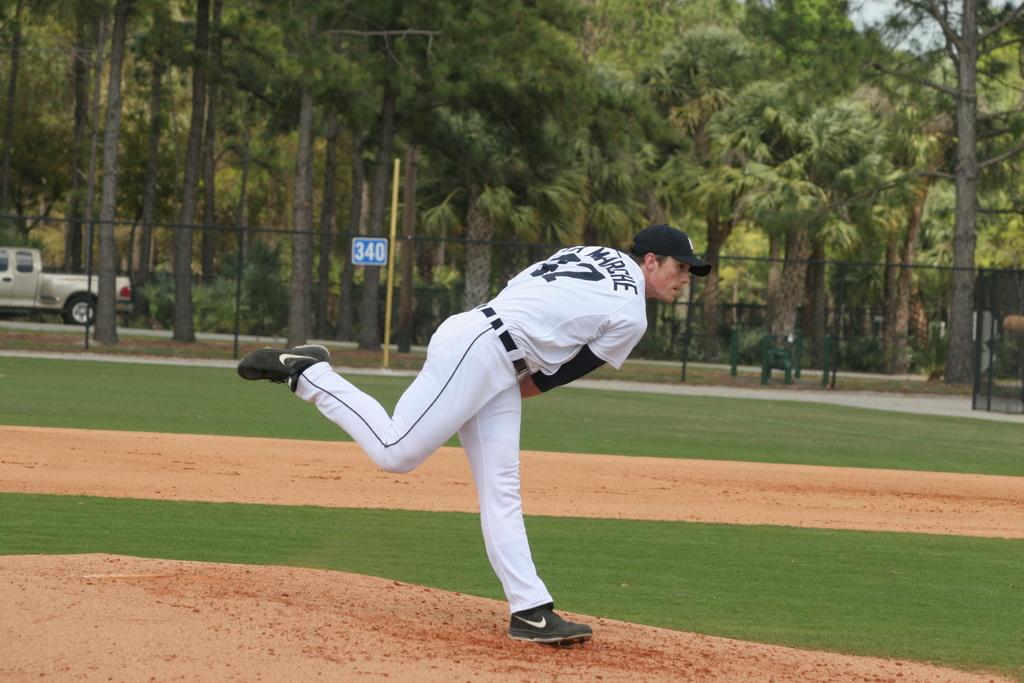What does the blue sign say?
Make the answer very short. 340. 